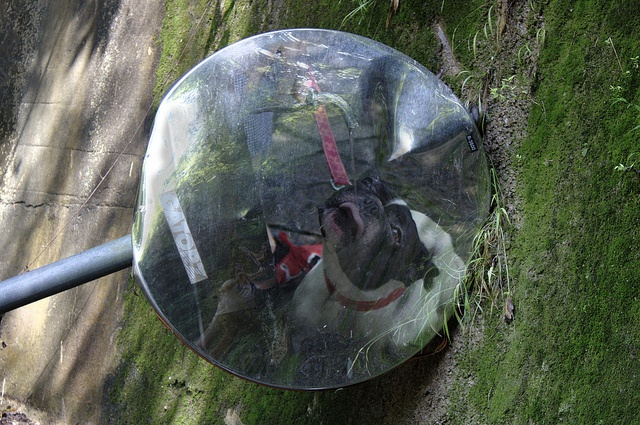Describe the objects in this image and their specific colors. I can see a dog in black, gray, and darkgray tones in this image. 